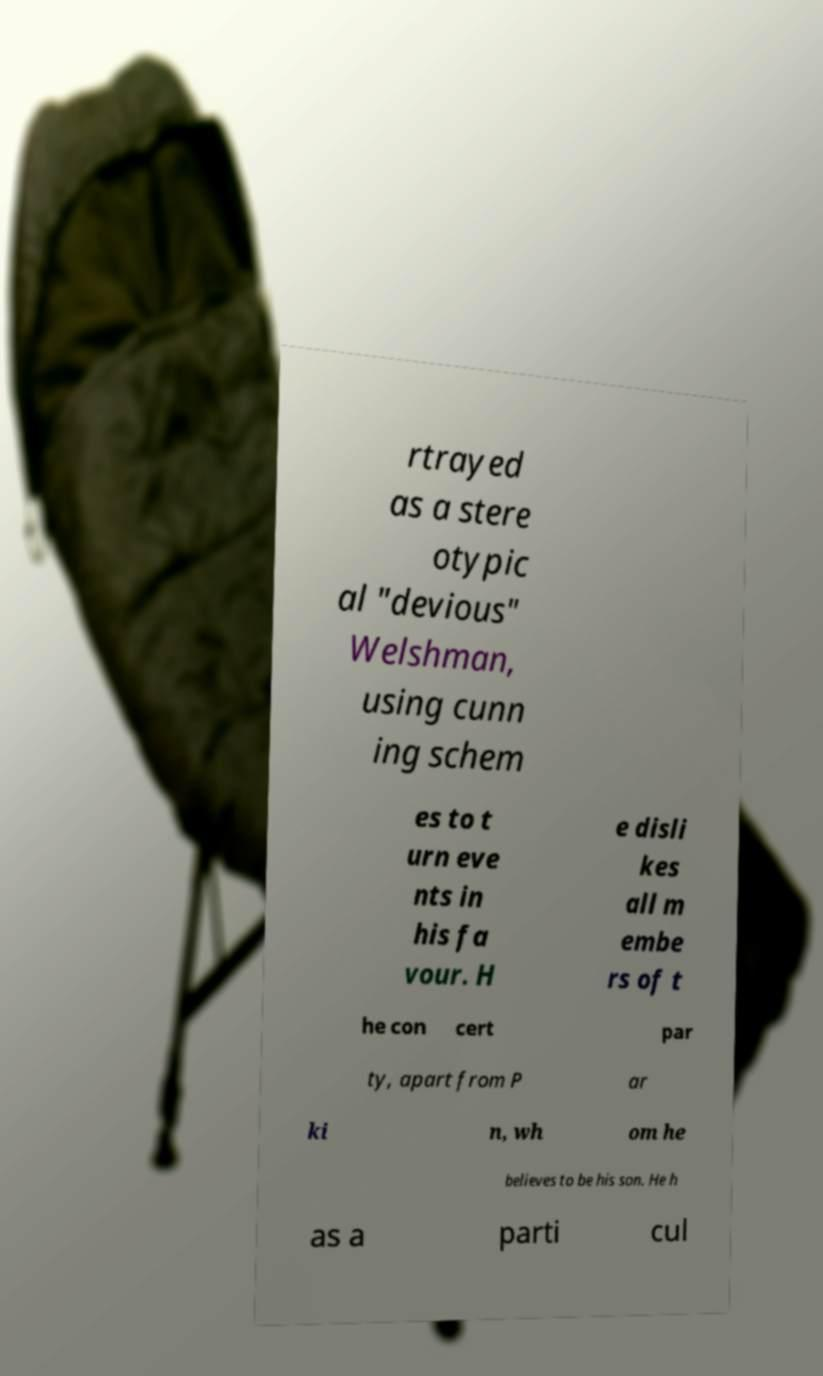What messages or text are displayed in this image? I need them in a readable, typed format. rtrayed as a stere otypic al "devious" Welshman, using cunn ing schem es to t urn eve nts in his fa vour. H e disli kes all m embe rs of t he con cert par ty, apart from P ar ki n, wh om he believes to be his son. He h as a parti cul 